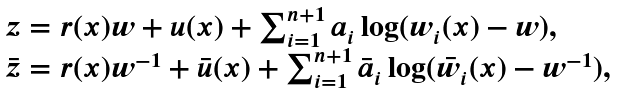Convert formula to latex. <formula><loc_0><loc_0><loc_500><loc_500>\begin{array} { l } z = r ( x ) w + u ( x ) + \sum _ { i = 1 } ^ { n + 1 } a _ { i } \log ( w _ { i } ( x ) - w ) , \\ \bar { z } = r ( x ) w ^ { - 1 } + \bar { u } ( x ) + \sum _ { i = 1 } ^ { n + 1 } \bar { a } _ { i } \log ( \bar { w } _ { i } ( x ) - w ^ { - 1 } ) , \end{array}</formula> 